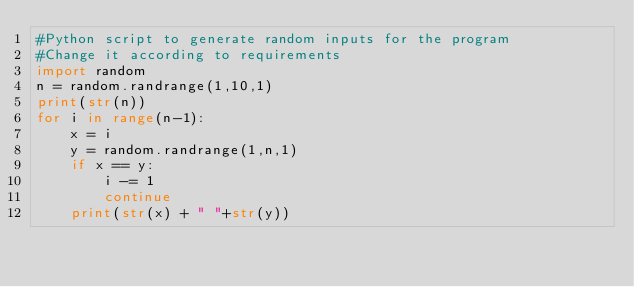Convert code to text. <code><loc_0><loc_0><loc_500><loc_500><_Python_>#Python script to generate random inputs for the program
#Change it according to requirements
import random
n = random.randrange(1,10,1)
print(str(n))
for i in range(n-1):
    x = i
    y = random.randrange(1,n,1)
    if x == y:
        i -= 1
        continue
    print(str(x) + " "+str(y))
</code> 